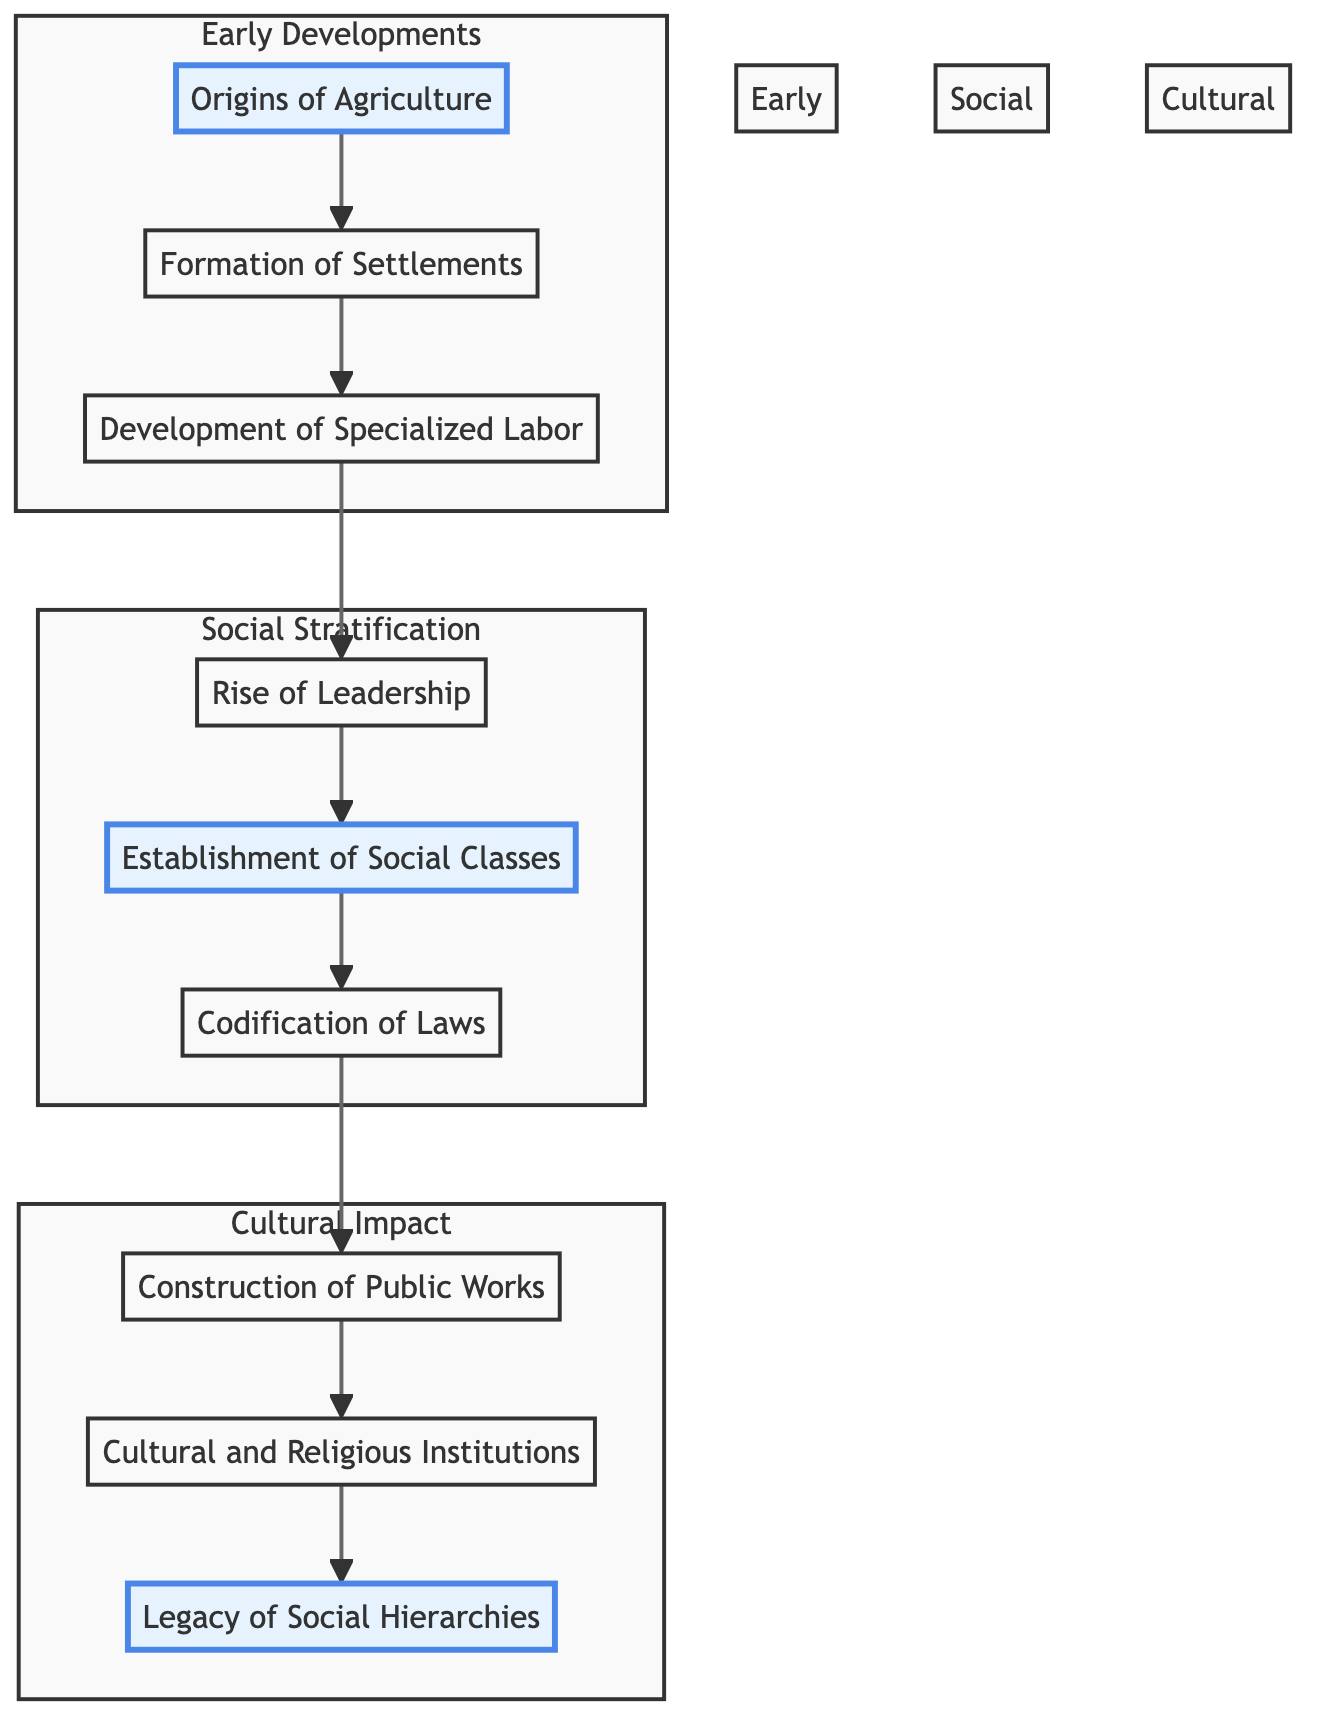What is the first step in the diagram? The diagram begins with "Origins of Agriculture," which is the starting point for the flow of information.
Answer: Origins of Agriculture How many major subgroups are identified in the diagram? There are three major subgroups: Early Developments, Social Stratification, and Cultural Impact, which categorize the steps based on their thematic connections.
Answer: 3 What step follows the establishment of social classes? After "Establishment of Social Classes," the flow progresses to "Codification of Laws," indicating the legal structuring that follows social hierarchy.
Answer: Codification of Laws Which step is highlighted in the flowchart as part of social stratification? "Establishment of Social Classes" is highlighted, as it signifies a pivotal moment in the creation of distinct social categories within Mesopotamian society.
Answer: Establishment of Social Classes What was a consequence of the rise of leadership? The "Rise of Leadership" led to the "Establishment of Social Classes," indicating that leadership was a critical factor in forming social stratification.
Answer: Establishment of Social Classes List one large-scale project mentioned in the diagram. The diagram references "Construction of Public Works," specifically noting large-scale projects like temples and irrigation systems that were managed by the elite.
Answer: Construction of Public Works What role did cultural and religious institutions play according to the diagram? The diagram states that "Cultural and Religious Institutions" played essential roles in maintaining social order, suggesting their importance in the overall structure of society.
Answer: Maintaining social order Which step comes at the end of the flowchart? The last step, concluding the series of developments and their impacts on society, is "Legacy of Social Hierarchies," representing long-term effects on cultures.
Answer: Legacy of Social Hierarchies How does the diagram show the relationship between agriculture and settlement formation? It illustrates that "Origins of Agriculture" leads directly to "Formation of Settlements," indicating that the food surplus enabled the establishment of permanent communities.
Answer: Formation of Settlements 